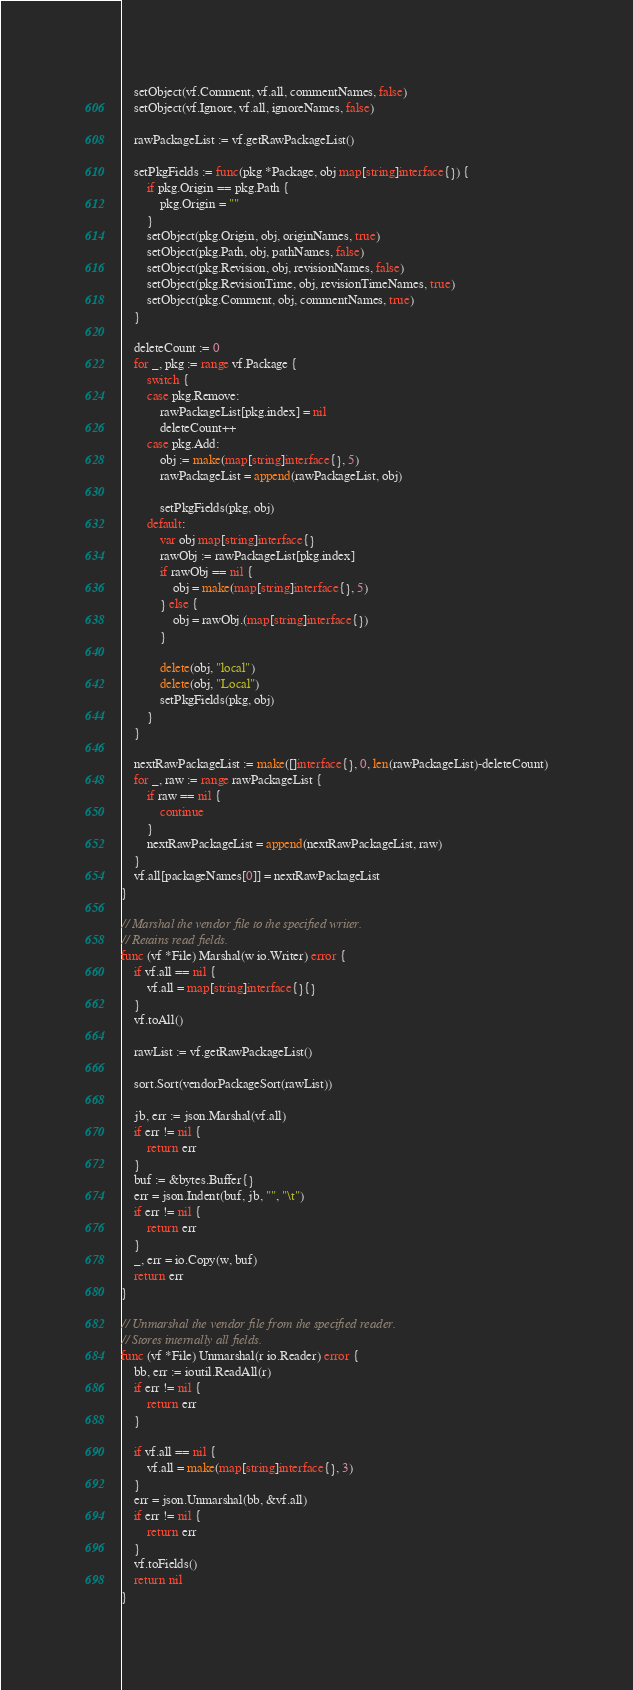Convert code to text. <code><loc_0><loc_0><loc_500><loc_500><_Go_>
	setObject(vf.Comment, vf.all, commentNames, false)
	setObject(vf.Ignore, vf.all, ignoreNames, false)

	rawPackageList := vf.getRawPackageList()

	setPkgFields := func(pkg *Package, obj map[string]interface{}) {
		if pkg.Origin == pkg.Path {
			pkg.Origin = ""
		}
		setObject(pkg.Origin, obj, originNames, true)
		setObject(pkg.Path, obj, pathNames, false)
		setObject(pkg.Revision, obj, revisionNames, false)
		setObject(pkg.RevisionTime, obj, revisionTimeNames, true)
		setObject(pkg.Comment, obj, commentNames, true)
	}

	deleteCount := 0
	for _, pkg := range vf.Package {
		switch {
		case pkg.Remove:
			rawPackageList[pkg.index] = nil
			deleteCount++
		case pkg.Add:
			obj := make(map[string]interface{}, 5)
			rawPackageList = append(rawPackageList, obj)

			setPkgFields(pkg, obj)
		default:
			var obj map[string]interface{}
			rawObj := rawPackageList[pkg.index]
			if rawObj == nil {
				obj = make(map[string]interface{}, 5)
			} else {
				obj = rawObj.(map[string]interface{})
			}

			delete(obj, "local")
			delete(obj, "Local")
			setPkgFields(pkg, obj)
		}
	}

	nextRawPackageList := make([]interface{}, 0, len(rawPackageList)-deleteCount)
	for _, raw := range rawPackageList {
		if raw == nil {
			continue
		}
		nextRawPackageList = append(nextRawPackageList, raw)
	}
	vf.all[packageNames[0]] = nextRawPackageList
}

// Marshal the vendor file to the specified writer.
// Retains read fields.
func (vf *File) Marshal(w io.Writer) error {
	if vf.all == nil {
		vf.all = map[string]interface{}{}
	}
	vf.toAll()

	rawList := vf.getRawPackageList()

	sort.Sort(vendorPackageSort(rawList))

	jb, err := json.Marshal(vf.all)
	if err != nil {
		return err
	}
	buf := &bytes.Buffer{}
	err = json.Indent(buf, jb, "", "\t")
	if err != nil {
		return err
	}
	_, err = io.Copy(w, buf)
	return err
}

// Unmarshal the vendor file from the specified reader.
// Stores internally all fields.
func (vf *File) Unmarshal(r io.Reader) error {
	bb, err := ioutil.ReadAll(r)
	if err != nil {
		return err
	}

	if vf.all == nil {
		vf.all = make(map[string]interface{}, 3)
	}
	err = json.Unmarshal(bb, &vf.all)
	if err != nil {
		return err
	}
	vf.toFields()
	return nil
}
</code> 